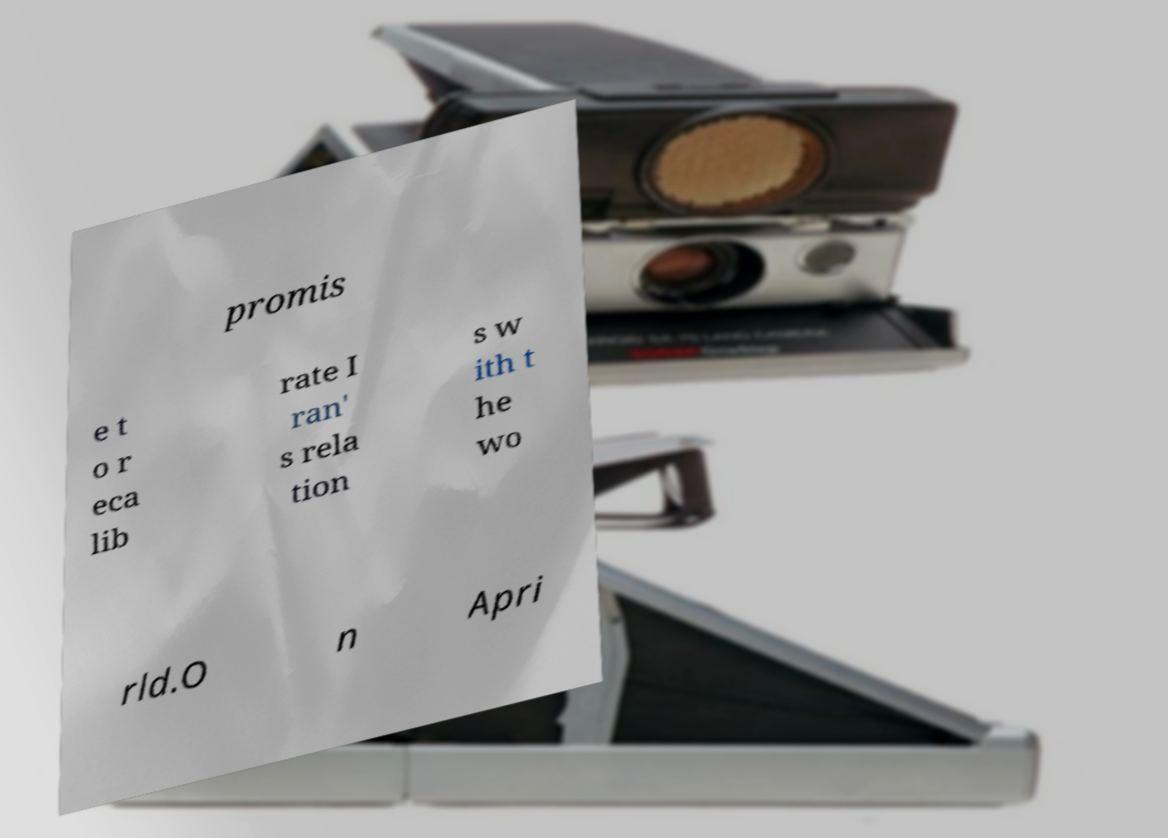Please read and relay the text visible in this image. What does it say? promis e t o r eca lib rate I ran' s rela tion s w ith t he wo rld.O n Apri 